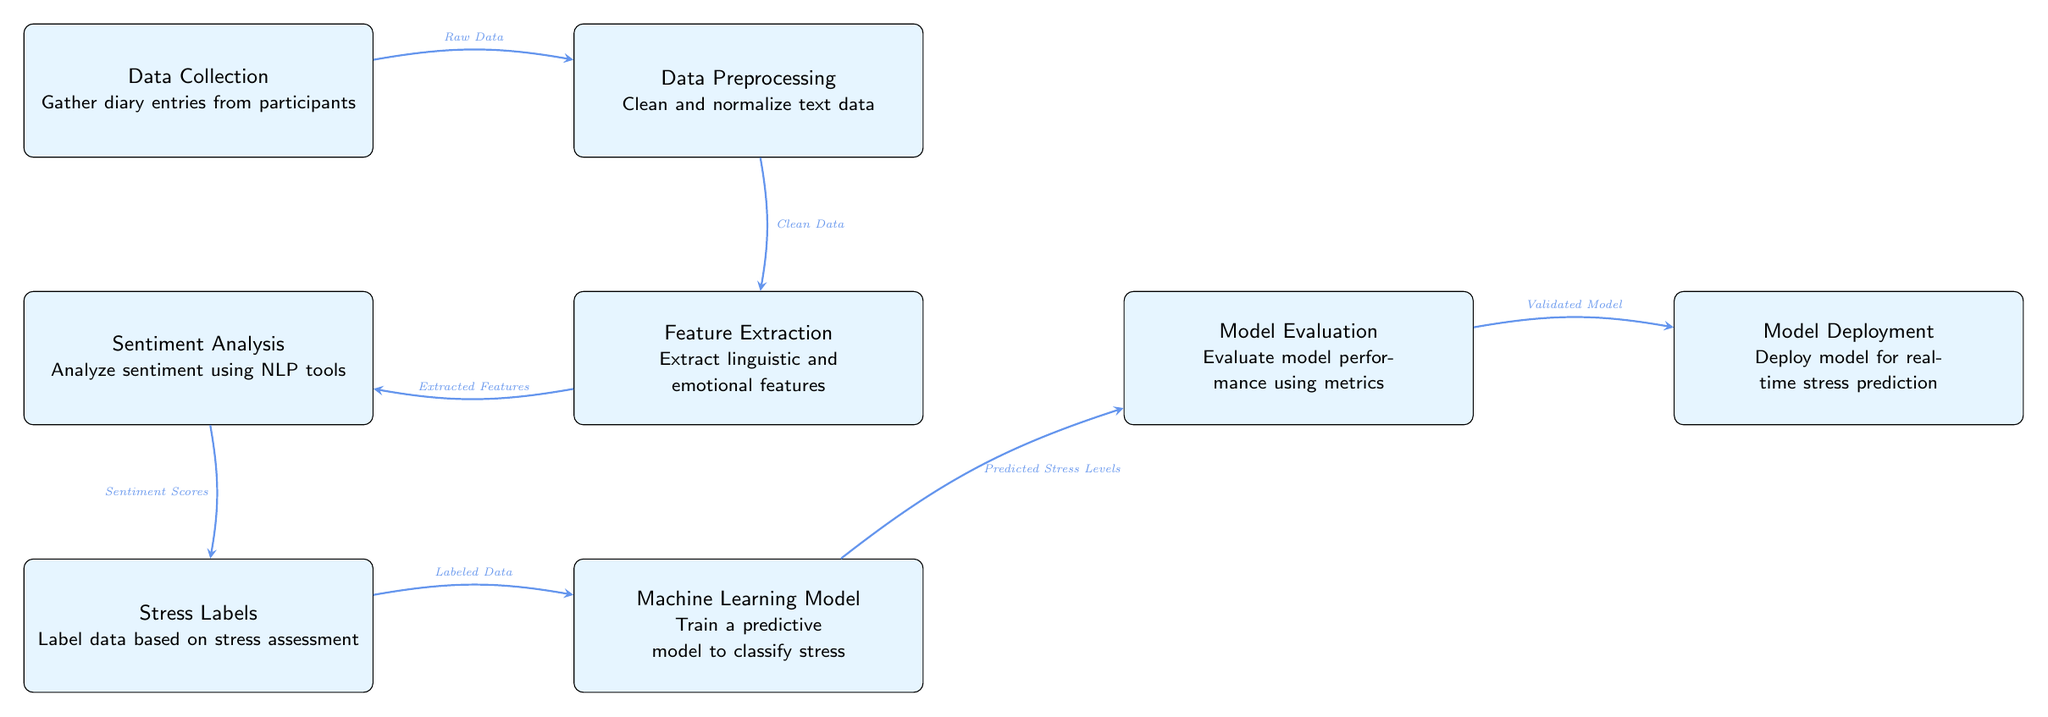What is the first step in the diagram? The first step in the diagram is "Data Collection," where diary entries from participants are gathered. This is indicated at the top left of the flowchart and serves as the initial process to gather raw data.
Answer: Data Collection How many nodes are represented in the diagram? By counting all the distinct boxes in the diagram, we see there are 7 nodes: Data Collection, Data Preprocessing, Feature Extraction, Sentiment Analysis, Stress Labels, Machine Learning Model, Model Evaluation, and Model Deployment.
Answer: 7 What type of data flows from "Data Collection" to "Data Preprocessing"? The flow from "Data Collection" to "Data Preprocessing" is labeled "Raw Data," indicating that the initial collected diary entries are sent for processing. This is shown as an arrow connecting these two steps in the diagram.
Answer: Raw Data What happens after "Model Evaluation"? After "Model Evaluation," the next step is "Model Deployment," meaning the validated model is then deployed for real-time stress prediction. This connection is made with an arrow pointing from evaluation to deployment.
Answer: Model Deployment Which node is responsible for labeling the data? The "Stress Labels" node is responsible for labeling the data based on stress assessment. This is illustrated in the diagram with an arrow leading into "Machine Learning Model," indicating the importance of labeled data for training.
Answer: Stress Labels What type of features are extracted during "Feature Extraction"? During "Feature Extraction," linguistic and emotional features are extracted from the diary entries. The diagram specifies these features in the description of this node, showing the focus on aspects relevant to stress prediction.
Answer: Linguistic and emotional features How is the model performance assessed in the diagram? Model performance is assessed in the "Model Evaluation" step, where the model is evaluated using specific metrics. This indicates that performance is gauged after predictions are made and before deployment occurs.
Answer: Model Evaluation What is the primary goal of the "Machine Learning Model" node? The primary goal of the "Machine Learning Model" node is to train a predictive model to classify stress levels based on the previously labeled data. This functionality is clearly indicated in the description associated with this node.
Answer: Train a predictive model to classify stress 